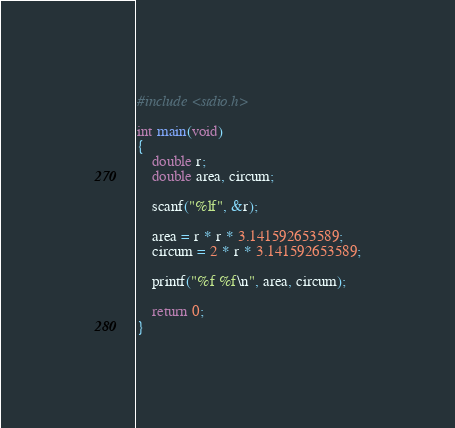Convert code to text. <code><loc_0><loc_0><loc_500><loc_500><_C_>#include <stdio.h>

int main(void)
{
	double r;
	double area, circum;

	scanf("%lf", &r);

	area = r * r * 3.141592653589;
	circum = 2 * r * 3.141592653589;

	printf("%f %f\n", area, circum);

	return 0;
}</code> 